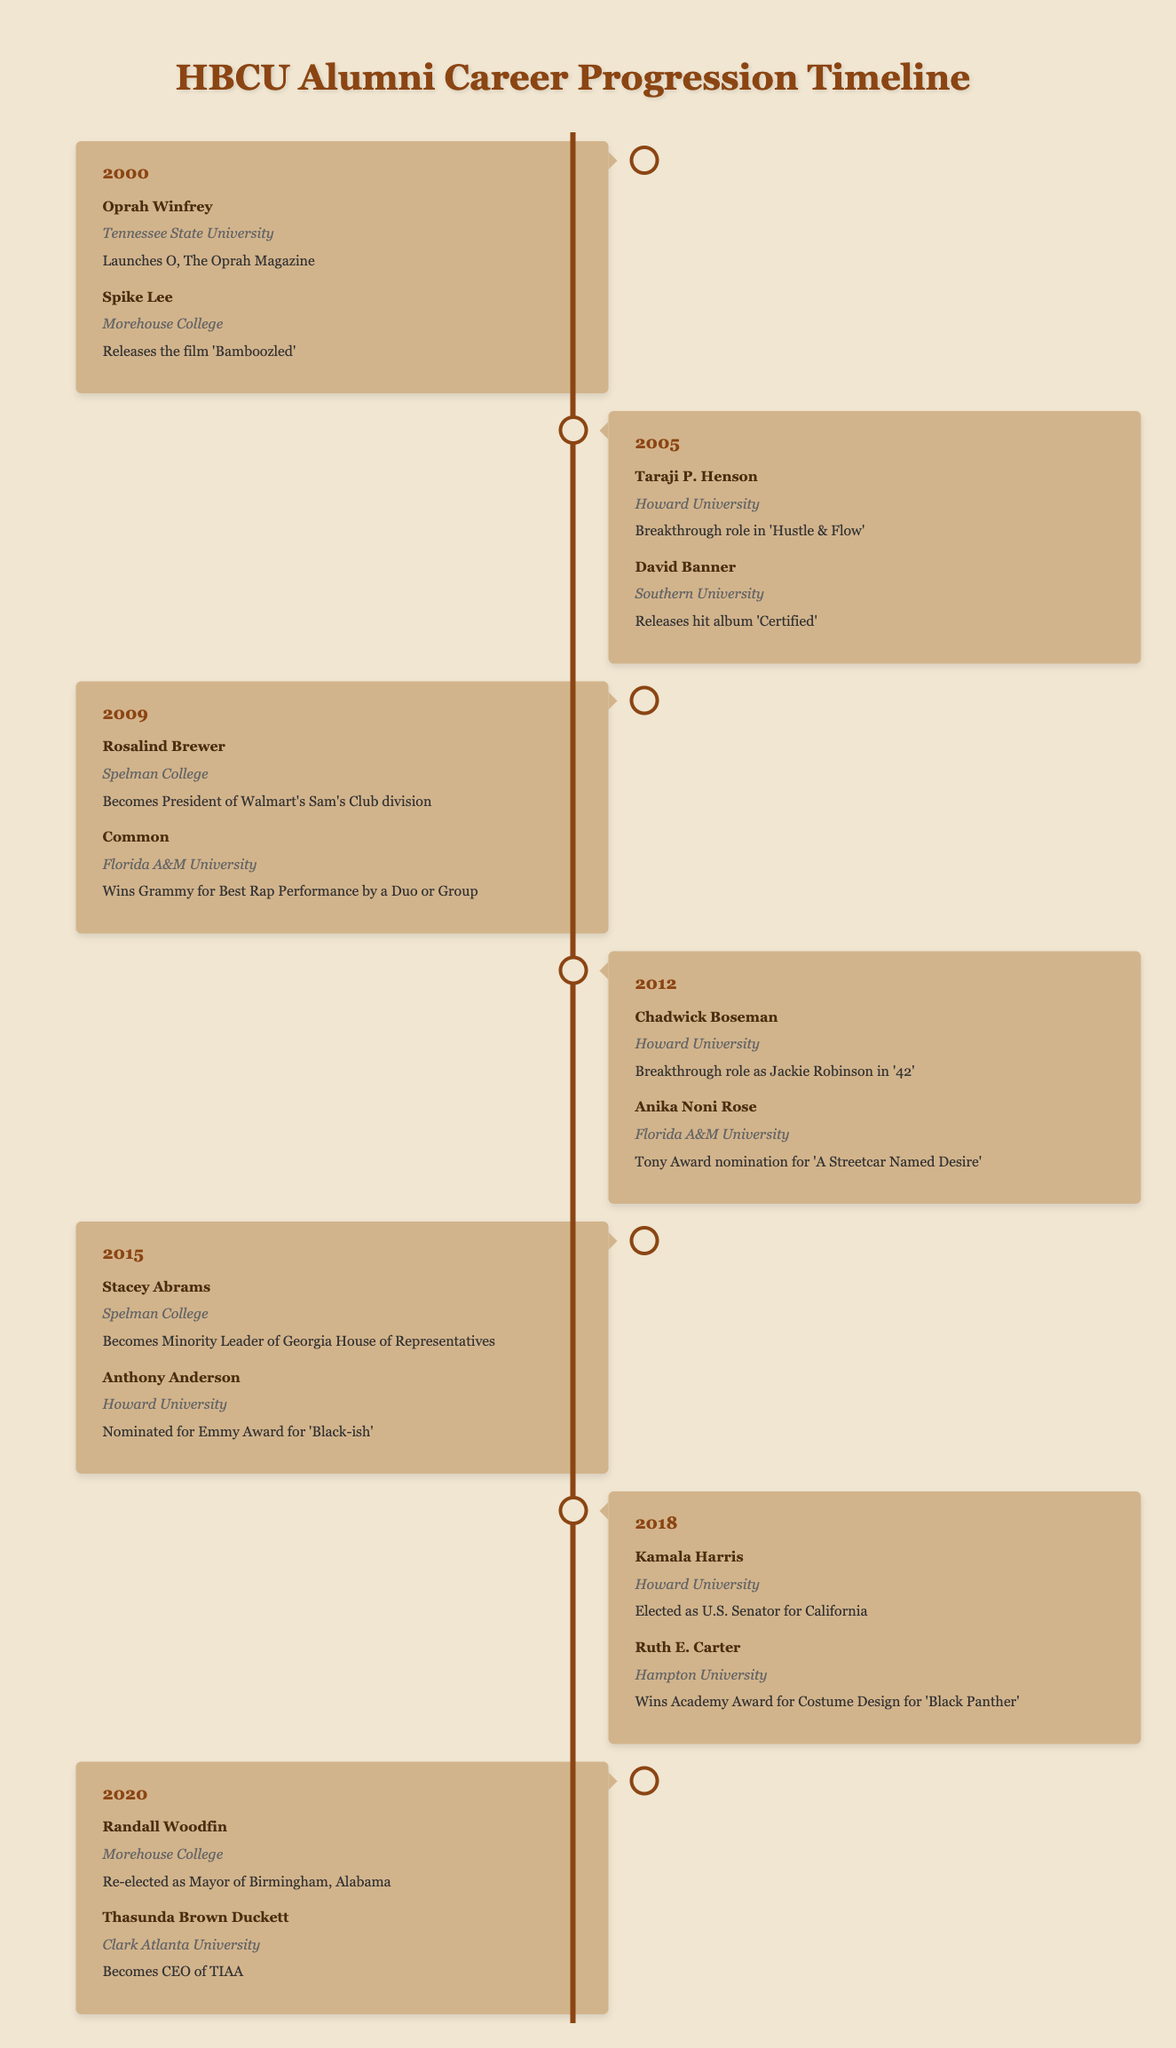What notable achievement did Kamala Harris have in 2018? Kamala Harris was elected as U.S. Senator for California in 2018. This information can be found by referring to the timeline for the year 2018.
Answer: Elected as U.S. Senator for California Which HBCU did Taraji P. Henson attend? Taraji P. Henson attended Howard University. This fact is directly listed next to her name in the 2005 section of the timeline.
Answer: Howard University How many alumni are mentioned in total for the year 2000? There are two alumni mentioned for the year 2000: Oprah Winfrey and Spike Lee. This is evident as there are two distinct entries listed under that year in the timeline.
Answer: 2 Did any notable alumni achieve an Academy Award for their work? Yes, Ruth E. Carter won an Academy Award for Costume Design for 'Black Panther' in 2018. This can be confirmed by checking the achievements listed under the year 2018.
Answer: Yes In which year did Chadwick Boseman break through with his role in '42'? Chadwick Boseman achieved his breakthrough role as Jackie Robinson in '42' in 2012. This information is clearly stated in the timeline under the year 2012.
Answer: 2012 Which HBCU has the highest representation in terms of notable alumni mentioned in this timeline? Howard University has the highest representation with four notable alumni mentioned: Taraji P. Henson, Chadwick Boseman, Anthony Anderson, and Kamala Harris. This can be determined by counting the number of entries associated with Howard University throughout the timeline.
Answer: Howard University What is the average year of achievement for the notable alumni listed? The achievements span across the years 2000, 2005, 2009, 2012, 2015, 2018, and 2020. The average can be calculated by summing these years (2000 + 2005 + 2009 + 2012 + 2015 + 2018 + 2020 = 14079) and dividing by the number of entries (7), giving 14079 / 7 = 2001.14, which rounds to 2001.
Answer: 2001 Who became the CEO of TIAA in 2020? Thasunda Brown Duckett became the CEO of TIAA in 2020. This detail is located in the timeline under the year 2020.
Answer: Thasunda Brown Duckett What was the achievement of Stacey Abrams in 2015? Stacey Abrams became the Minority Leader of the Georgia House of Representatives in 2015. This information is found in the timeline under the year 2015.
Answer: Minority Leader of Georgia House of Representatives 